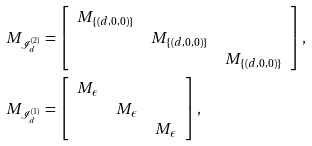<formula> <loc_0><loc_0><loc_500><loc_500>& M _ { \mathcal { I } _ { d } ^ { ( 2 ) } } = \left [ \begin{array} { c c c } M _ { \{ ( d , 0 , 0 ) \} } & & \\ & M _ { \{ ( d , 0 , 0 ) \} } & \\ & & M _ { \{ ( d , 0 , 0 ) \} } \end{array} \right ] , \\ & M _ { \mathcal { I } _ { d } ^ { ( 1 ) } } = \left [ \begin{array} { c c c } M _ { \epsilon } & & \\ & M _ { \epsilon } & \\ & & M _ { \epsilon } \end{array} \right ] ,</formula> 